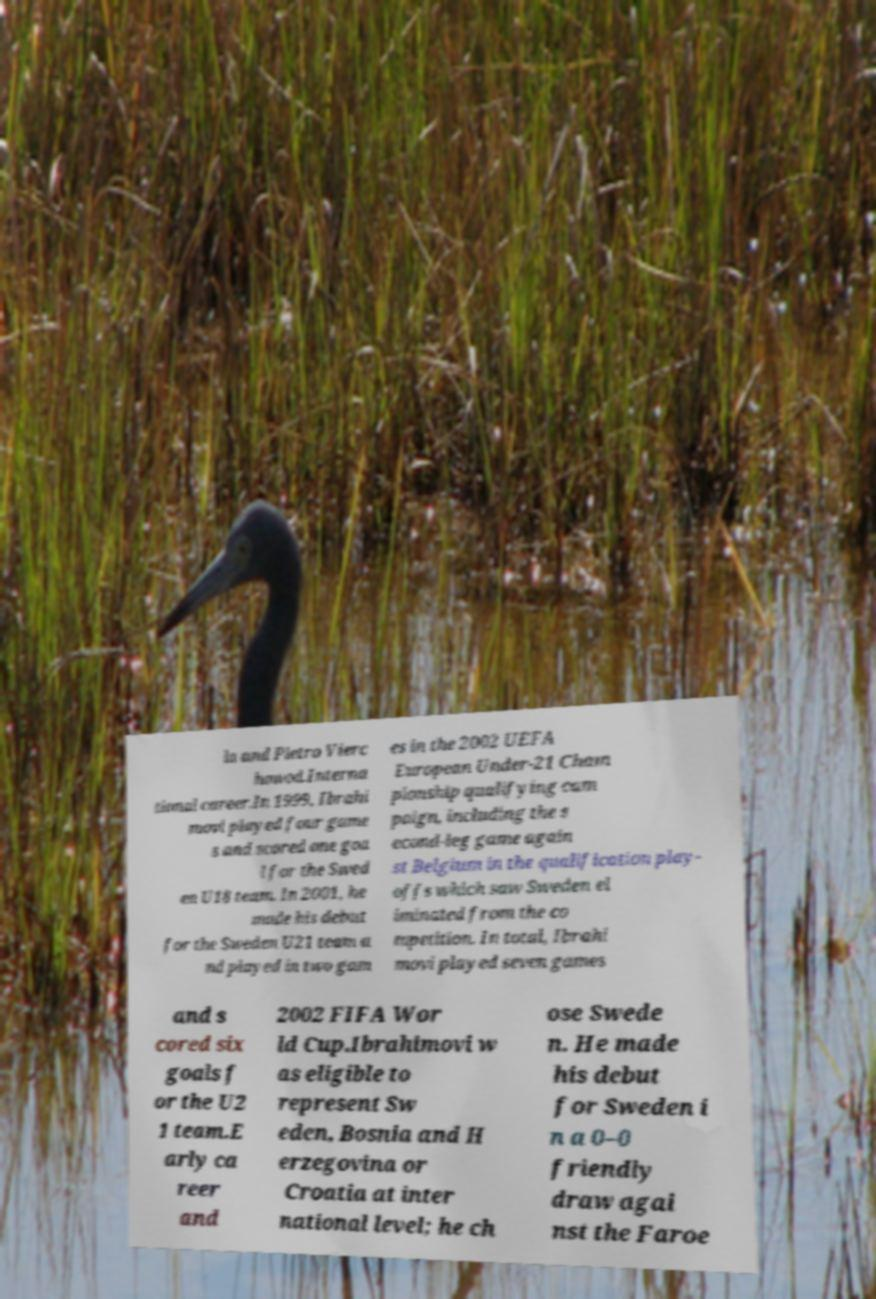Please read and relay the text visible in this image. What does it say? la and Pietro Vierc howod.Interna tional career.In 1999, Ibrahi movi played four game s and scored one goa l for the Swed en U18 team. In 2001, he made his debut for the Sweden U21 team a nd played in two gam es in the 2002 UEFA European Under-21 Cham pionship qualifying cam paign, including the s econd-leg game again st Belgium in the qualification play- offs which saw Sweden el iminated from the co mpetition. In total, Ibrahi movi played seven games and s cored six goals f or the U2 1 team.E arly ca reer and 2002 FIFA Wor ld Cup.Ibrahimovi w as eligible to represent Sw eden, Bosnia and H erzegovina or Croatia at inter national level; he ch ose Swede n. He made his debut for Sweden i n a 0–0 friendly draw agai nst the Faroe 